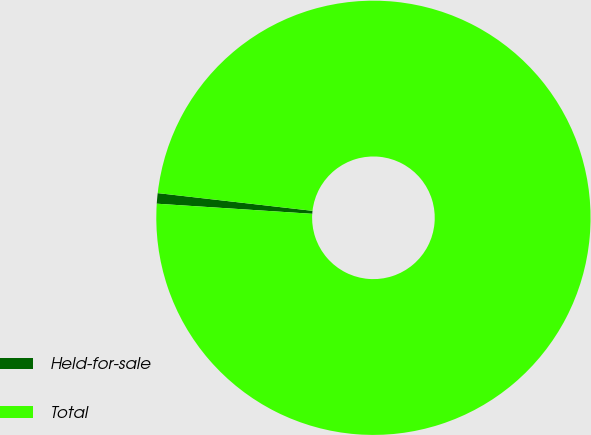<chart> <loc_0><loc_0><loc_500><loc_500><pie_chart><fcel>Held-for-sale<fcel>Total<nl><fcel>0.78%<fcel>99.22%<nl></chart> 